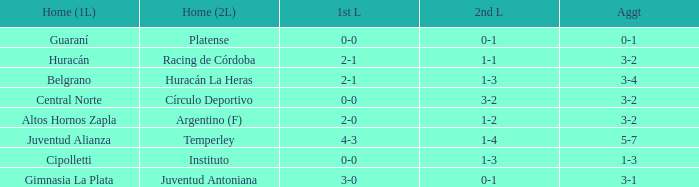Who played at home for the second leg with a score of 0-1 and tied 0-0 in the first leg? Platense. Can you give me this table as a dict? {'header': ['Home (1L)', 'Home (2L)', '1st L', '2nd L', 'Aggt'], 'rows': [['Guaraní', 'Platense', '0-0', '0-1', '0-1'], ['Huracán', 'Racing de Córdoba', '2-1', '1-1', '3-2'], ['Belgrano', 'Huracán La Heras', '2-1', '1-3', '3-4'], ['Central Norte', 'Círculo Deportivo', '0-0', '3-2', '3-2'], ['Altos Hornos Zapla', 'Argentino (F)', '2-0', '1-2', '3-2'], ['Juventud Alianza', 'Temperley', '4-3', '1-4', '5-7'], ['Cipolletti', 'Instituto', '0-0', '1-3', '1-3'], ['Gimnasia La Plata', 'Juventud Antoniana', '3-0', '0-1', '3-1']]} 